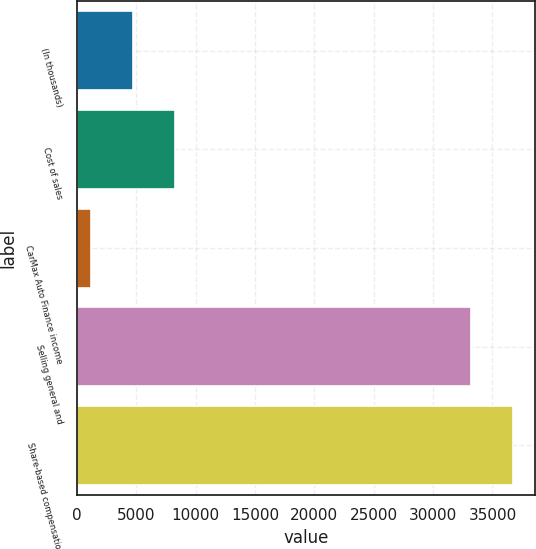Convert chart. <chart><loc_0><loc_0><loc_500><loc_500><bar_chart><fcel>(In thousands)<fcel>Cost of sales<fcel>CarMax Auto Finance income<fcel>Selling general and<fcel>Share-based compensation<nl><fcel>4714.7<fcel>8248.4<fcel>1181<fcel>33201<fcel>36734.7<nl></chart> 